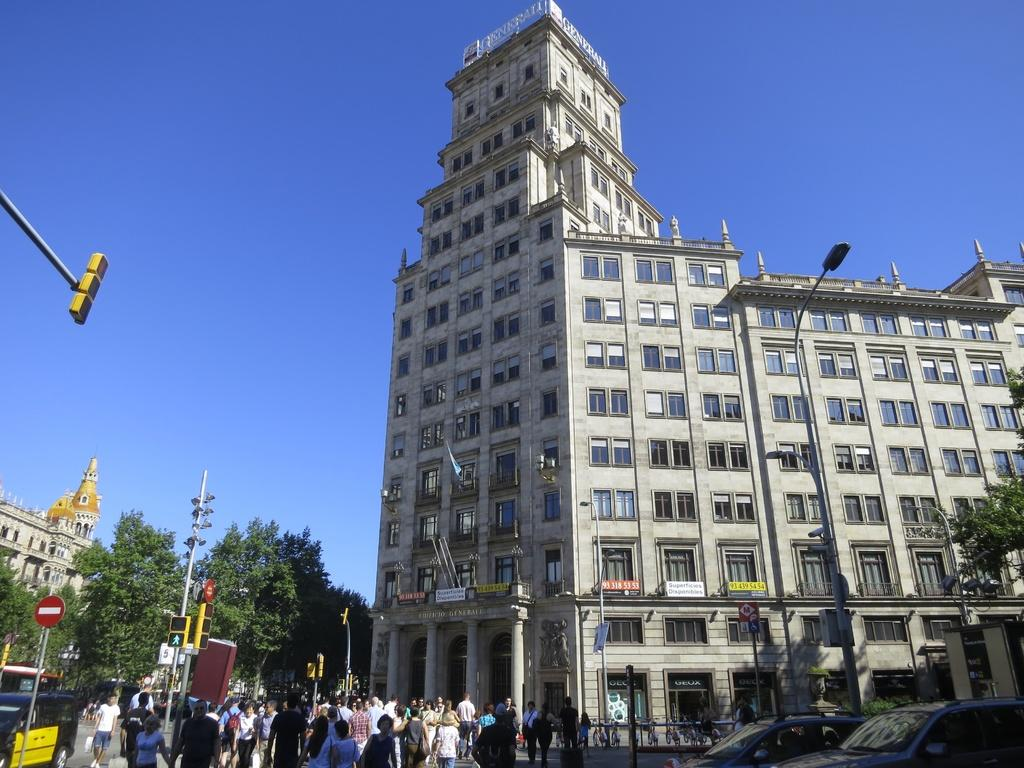What are the people in the image doing? There is a group of people walking in the image. What can be seen controlling the traffic in the image? There is a traffic signal in the image. What structures are present to provide light at night in the image? There are light poles in the image. What color are the buildings in the image? There are buildings in white color in the image. What type of vegetation is present in the image? There are trees in green color in the image. What color is the sky in the image? The sky is in blue color in the image. What type of cork can be seen in the design of the front of the building in the image? There is no cork present in the image, nor is there any mention of a design on the front of the building. 